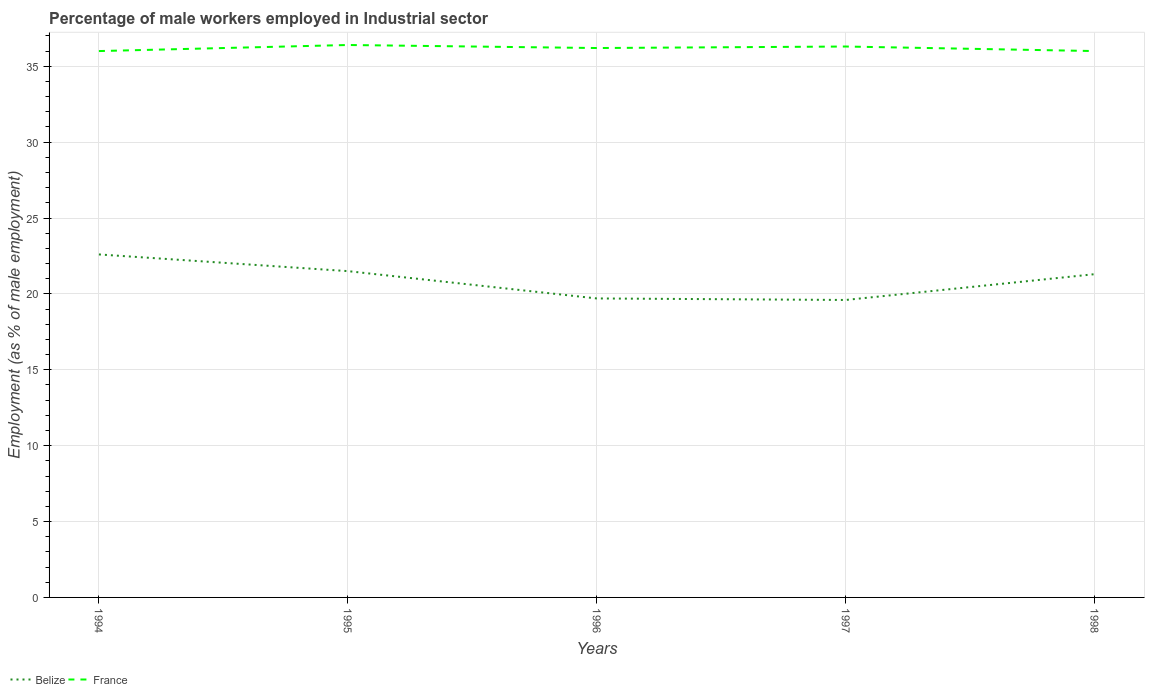Is the number of lines equal to the number of legend labels?
Your response must be concise. Yes. Across all years, what is the maximum percentage of male workers employed in Industrial sector in Belize?
Your answer should be very brief. 19.6. What is the total percentage of male workers employed in Industrial sector in Belize in the graph?
Ensure brevity in your answer.  2.9. What is the difference between the highest and the second highest percentage of male workers employed in Industrial sector in France?
Keep it short and to the point. 0.4. How many years are there in the graph?
Your answer should be very brief. 5. What is the difference between two consecutive major ticks on the Y-axis?
Provide a succinct answer. 5. Does the graph contain any zero values?
Give a very brief answer. No. Does the graph contain grids?
Keep it short and to the point. Yes. How many legend labels are there?
Keep it short and to the point. 2. What is the title of the graph?
Keep it short and to the point. Percentage of male workers employed in Industrial sector. What is the label or title of the X-axis?
Provide a short and direct response. Years. What is the label or title of the Y-axis?
Offer a terse response. Employment (as % of male employment). What is the Employment (as % of male employment) in Belize in 1994?
Provide a succinct answer. 22.6. What is the Employment (as % of male employment) of Belize in 1995?
Your answer should be compact. 21.5. What is the Employment (as % of male employment) in France in 1995?
Your response must be concise. 36.4. What is the Employment (as % of male employment) of Belize in 1996?
Your response must be concise. 19.7. What is the Employment (as % of male employment) of France in 1996?
Your answer should be compact. 36.2. What is the Employment (as % of male employment) in Belize in 1997?
Offer a very short reply. 19.6. What is the Employment (as % of male employment) in France in 1997?
Your answer should be very brief. 36.3. What is the Employment (as % of male employment) of Belize in 1998?
Your response must be concise. 21.3. What is the Employment (as % of male employment) in France in 1998?
Your response must be concise. 36. Across all years, what is the maximum Employment (as % of male employment) in Belize?
Your response must be concise. 22.6. Across all years, what is the maximum Employment (as % of male employment) in France?
Offer a very short reply. 36.4. Across all years, what is the minimum Employment (as % of male employment) in Belize?
Provide a short and direct response. 19.6. What is the total Employment (as % of male employment) of Belize in the graph?
Make the answer very short. 104.7. What is the total Employment (as % of male employment) in France in the graph?
Your answer should be very brief. 180.9. What is the difference between the Employment (as % of male employment) in Belize in 1994 and that in 1996?
Keep it short and to the point. 2.9. What is the difference between the Employment (as % of male employment) in Belize in 1994 and that in 1997?
Give a very brief answer. 3. What is the difference between the Employment (as % of male employment) in Belize in 1994 and that in 1998?
Ensure brevity in your answer.  1.3. What is the difference between the Employment (as % of male employment) of France in 1994 and that in 1998?
Offer a very short reply. 0. What is the difference between the Employment (as % of male employment) of Belize in 1995 and that in 1996?
Keep it short and to the point. 1.8. What is the difference between the Employment (as % of male employment) in France in 1995 and that in 1996?
Your answer should be very brief. 0.2. What is the difference between the Employment (as % of male employment) of Belize in 1995 and that in 1997?
Make the answer very short. 1.9. What is the difference between the Employment (as % of male employment) of France in 1995 and that in 1997?
Ensure brevity in your answer.  0.1. What is the difference between the Employment (as % of male employment) in Belize in 1995 and that in 1998?
Offer a very short reply. 0.2. What is the difference between the Employment (as % of male employment) in France in 1995 and that in 1998?
Offer a terse response. 0.4. What is the difference between the Employment (as % of male employment) of Belize in 1996 and that in 1998?
Offer a terse response. -1.6. What is the difference between the Employment (as % of male employment) of France in 1996 and that in 1998?
Your answer should be very brief. 0.2. What is the difference between the Employment (as % of male employment) of France in 1997 and that in 1998?
Give a very brief answer. 0.3. What is the difference between the Employment (as % of male employment) of Belize in 1994 and the Employment (as % of male employment) of France in 1996?
Your answer should be very brief. -13.6. What is the difference between the Employment (as % of male employment) in Belize in 1994 and the Employment (as % of male employment) in France in 1997?
Offer a very short reply. -13.7. What is the difference between the Employment (as % of male employment) in Belize in 1994 and the Employment (as % of male employment) in France in 1998?
Provide a succinct answer. -13.4. What is the difference between the Employment (as % of male employment) of Belize in 1995 and the Employment (as % of male employment) of France in 1996?
Offer a terse response. -14.7. What is the difference between the Employment (as % of male employment) of Belize in 1995 and the Employment (as % of male employment) of France in 1997?
Provide a succinct answer. -14.8. What is the difference between the Employment (as % of male employment) of Belize in 1995 and the Employment (as % of male employment) of France in 1998?
Provide a short and direct response. -14.5. What is the difference between the Employment (as % of male employment) in Belize in 1996 and the Employment (as % of male employment) in France in 1997?
Make the answer very short. -16.6. What is the difference between the Employment (as % of male employment) of Belize in 1996 and the Employment (as % of male employment) of France in 1998?
Offer a terse response. -16.3. What is the difference between the Employment (as % of male employment) in Belize in 1997 and the Employment (as % of male employment) in France in 1998?
Ensure brevity in your answer.  -16.4. What is the average Employment (as % of male employment) of Belize per year?
Ensure brevity in your answer.  20.94. What is the average Employment (as % of male employment) in France per year?
Provide a succinct answer. 36.18. In the year 1994, what is the difference between the Employment (as % of male employment) in Belize and Employment (as % of male employment) in France?
Provide a succinct answer. -13.4. In the year 1995, what is the difference between the Employment (as % of male employment) in Belize and Employment (as % of male employment) in France?
Provide a short and direct response. -14.9. In the year 1996, what is the difference between the Employment (as % of male employment) in Belize and Employment (as % of male employment) in France?
Provide a succinct answer. -16.5. In the year 1997, what is the difference between the Employment (as % of male employment) in Belize and Employment (as % of male employment) in France?
Your answer should be very brief. -16.7. In the year 1998, what is the difference between the Employment (as % of male employment) in Belize and Employment (as % of male employment) in France?
Provide a succinct answer. -14.7. What is the ratio of the Employment (as % of male employment) in Belize in 1994 to that in 1995?
Make the answer very short. 1.05. What is the ratio of the Employment (as % of male employment) in France in 1994 to that in 1995?
Your answer should be compact. 0.99. What is the ratio of the Employment (as % of male employment) of Belize in 1994 to that in 1996?
Offer a very short reply. 1.15. What is the ratio of the Employment (as % of male employment) in France in 1994 to that in 1996?
Give a very brief answer. 0.99. What is the ratio of the Employment (as % of male employment) in Belize in 1994 to that in 1997?
Provide a succinct answer. 1.15. What is the ratio of the Employment (as % of male employment) of France in 1994 to that in 1997?
Ensure brevity in your answer.  0.99. What is the ratio of the Employment (as % of male employment) in Belize in 1994 to that in 1998?
Provide a succinct answer. 1.06. What is the ratio of the Employment (as % of male employment) in France in 1994 to that in 1998?
Offer a terse response. 1. What is the ratio of the Employment (as % of male employment) in Belize in 1995 to that in 1996?
Ensure brevity in your answer.  1.09. What is the ratio of the Employment (as % of male employment) in Belize in 1995 to that in 1997?
Give a very brief answer. 1.1. What is the ratio of the Employment (as % of male employment) of Belize in 1995 to that in 1998?
Make the answer very short. 1.01. What is the ratio of the Employment (as % of male employment) in France in 1995 to that in 1998?
Your answer should be very brief. 1.01. What is the ratio of the Employment (as % of male employment) of Belize in 1996 to that in 1998?
Provide a short and direct response. 0.92. What is the ratio of the Employment (as % of male employment) in France in 1996 to that in 1998?
Give a very brief answer. 1.01. What is the ratio of the Employment (as % of male employment) in Belize in 1997 to that in 1998?
Your response must be concise. 0.92. What is the ratio of the Employment (as % of male employment) in France in 1997 to that in 1998?
Make the answer very short. 1.01. What is the difference between the highest and the second highest Employment (as % of male employment) of Belize?
Keep it short and to the point. 1.1. What is the difference between the highest and the lowest Employment (as % of male employment) in Belize?
Provide a short and direct response. 3. 